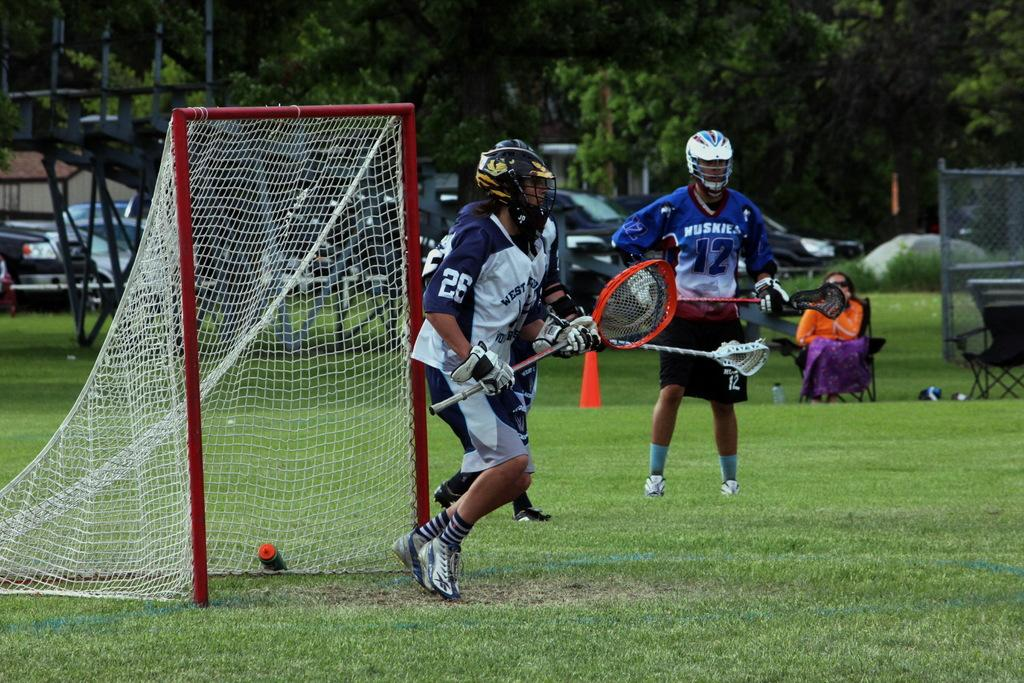<image>
Offer a succinct explanation of the picture presented. Lacrosse player number 26 is guarding the net. 